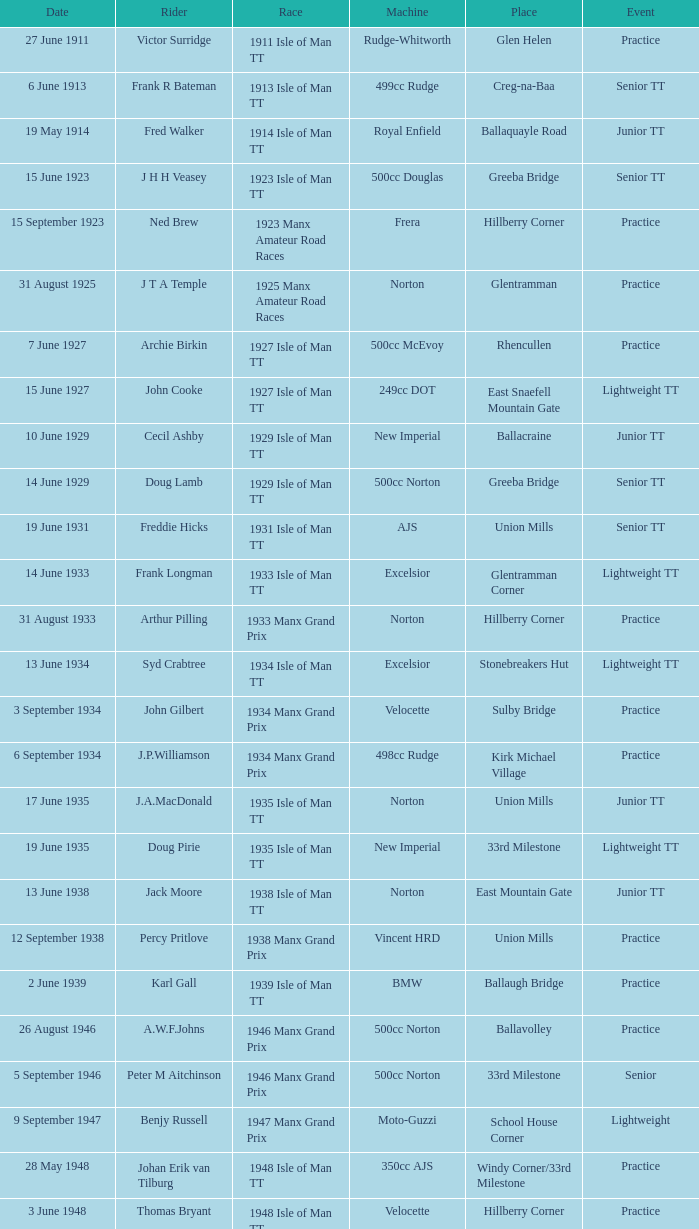What event was Rob Vine riding? Senior TT. 